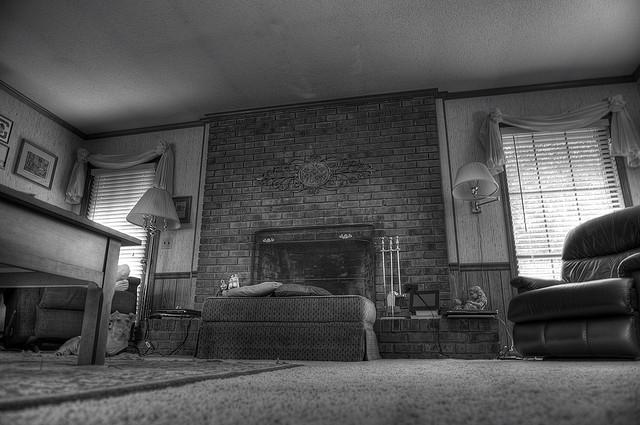Which side is the leather side?
Give a very brief answer. Right. How many lamps are there?
Quick response, please. 2. Does this photo reflect the decorating style of the 1980's?
Write a very short answer. Yes. 